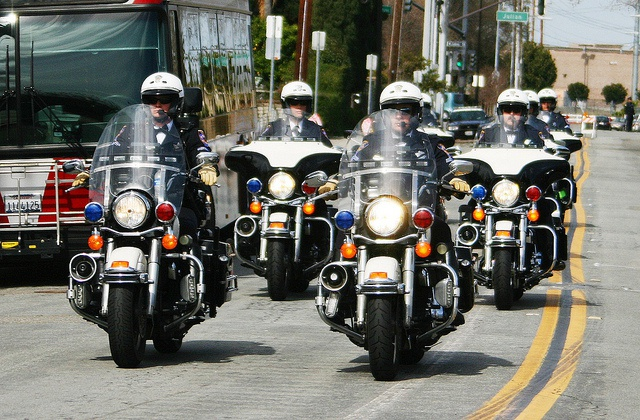Describe the objects in this image and their specific colors. I can see bus in black, gray, darkgray, and teal tones, motorcycle in black, gray, darkgray, and lightgray tones, motorcycle in black, lightgray, gray, and darkgray tones, motorcycle in black, white, gray, and darkgray tones, and motorcycle in black, white, gray, and darkgray tones in this image. 